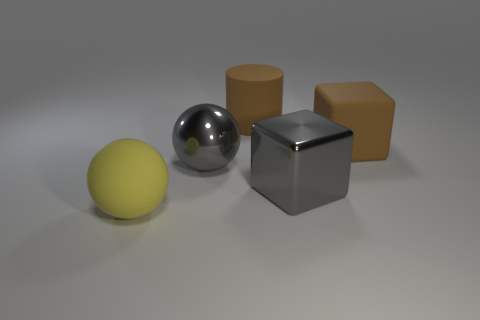Add 3 big cyan balls. How many objects exist? 8 Subtract all cylinders. How many objects are left? 4 Subtract all brown rubber objects. Subtract all big gray metal spheres. How many objects are left? 2 Add 4 large brown rubber cylinders. How many large brown rubber cylinders are left? 5 Add 3 large brown blocks. How many large brown blocks exist? 4 Subtract 1 brown cubes. How many objects are left? 4 